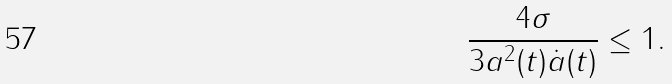Convert formula to latex. <formula><loc_0><loc_0><loc_500><loc_500>\frac { 4 \sigma } { 3 a ^ { 2 } ( t ) \dot { a } ( t ) } \leq 1 .</formula> 